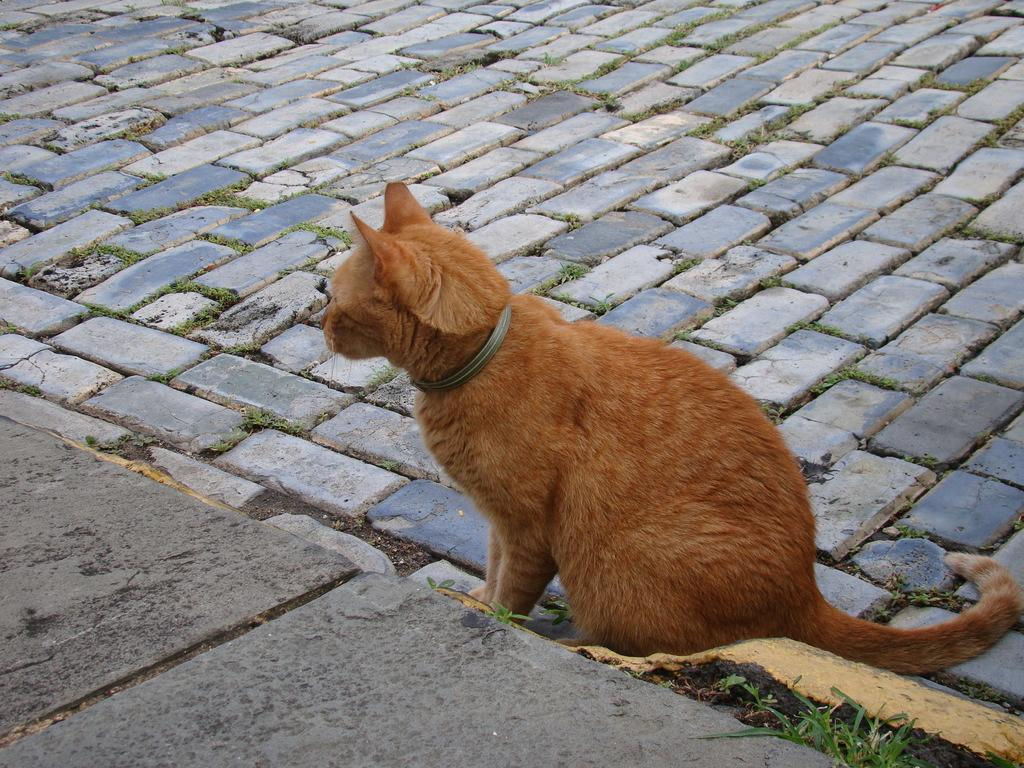What type of animal is in the picture? There is a cat in the picture. What color is the cat? The cat is brown in color. Where is the cat located in the picture? The cat is on the ground. What else can be seen on the ground in the picture? There is a leash and cobblestones visible on the ground. What type of rock is the cat holding in the image? There is no rock present in the image, and the cat is not holding anything. 